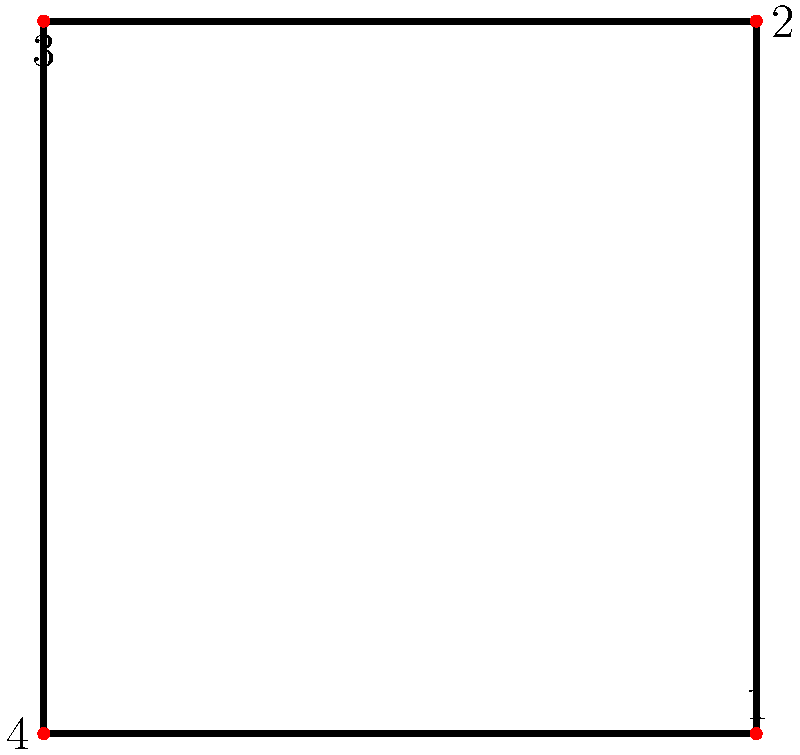In a classic Wuxia film, Donnie Yen demonstrates a martial arts stance represented by the square diagram above. Each corner of the square represents a different position in the stance. What is the order of the cyclic group of rotational symmetries for this stance diagram? To determine the order of the cyclic group of rotational symmetries for this stance diagram, we need to follow these steps:

1. Identify the shape: The diagram is a square.

2. Determine possible rotations:
   - 0° (identity rotation)
   - 90° clockwise
   - 180° (half turn)
   - 270° clockwise (or 90° counterclockwise)

3. Count the number of distinct rotations:
   There are 4 distinct rotations that bring the square back to a position indistinguishable from its starting position.

4. Understand the group structure:
   These rotations form a cyclic group under composition, as each rotation can be generated by repeatedly applying the 90° rotation.

5. Determine the order of the group:
   The order of a group is the number of elements in the group. In this case, there are 4 elements (rotations) in the group.

Therefore, the order of the cyclic group of rotational symmetries for this stance diagram is 4.
Answer: 4 